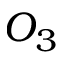<formula> <loc_0><loc_0><loc_500><loc_500>O _ { 3 }</formula> 